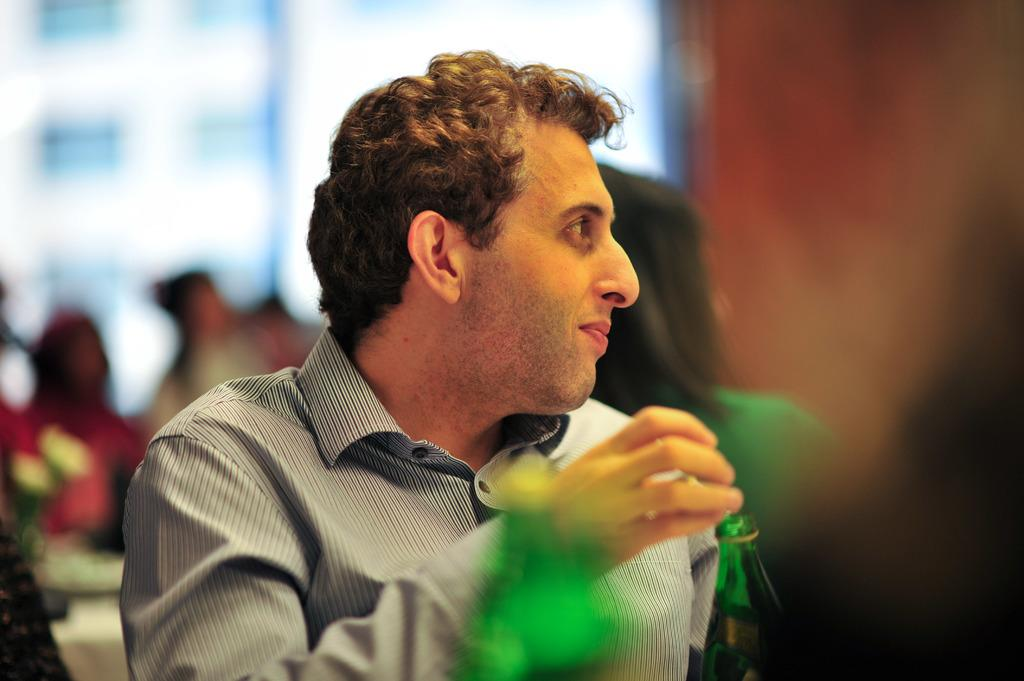Who is present in the image? There is a man in the image. What is the man doing in the image? The man is smiling in the image. What is the man sitting on in the image? The man is sitting on a chair in the image. Where is the chair located in relation to the table? The chair is near a table in the image. What is the man holding in his hands? The man is holding a bottle in his hands in the image. Can you tell me how the river flows in the image? There is no river present in the image; it features a man sitting on a chair and holding a bottle. 